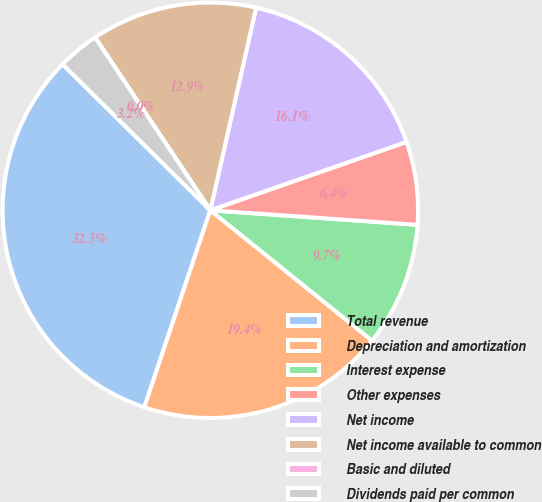Convert chart to OTSL. <chart><loc_0><loc_0><loc_500><loc_500><pie_chart><fcel>Total revenue<fcel>Depreciation and amortization<fcel>Interest expense<fcel>Other expenses<fcel>Net income<fcel>Net income available to common<fcel>Basic and diluted<fcel>Dividends paid per common<nl><fcel>32.26%<fcel>19.35%<fcel>9.68%<fcel>6.45%<fcel>16.13%<fcel>12.9%<fcel>0.0%<fcel>3.23%<nl></chart> 